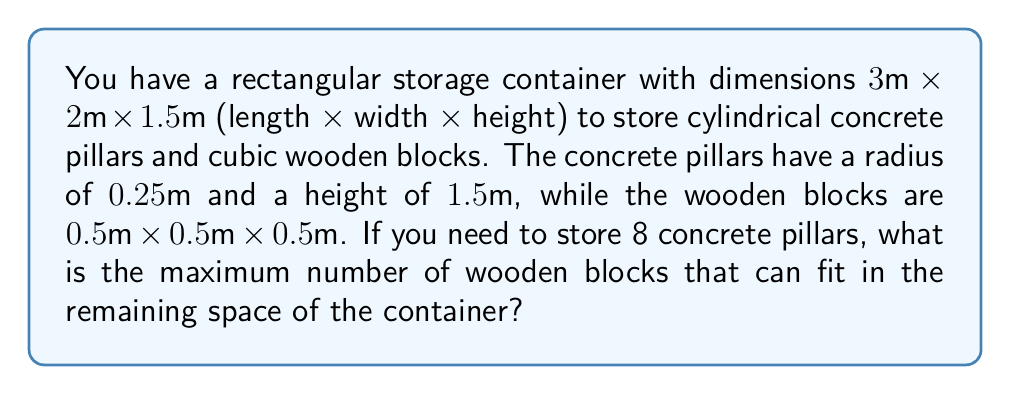Teach me how to tackle this problem. Let's approach this problem step by step:

1. Calculate the volume of the storage container:
   $$V_{container} = 3m \times 2m \times 1.5m = 9m^3$$

2. Calculate the volume of one concrete pillar:
   $$V_{pillar} = \pi r^2 h = \pi \times (0.25m)^2 \times 1.5m \approx 0.2945m^3$$

3. Calculate the total volume occupied by 8 pillars:
   $$V_{8pillars} = 8 \times 0.2945m^3 = 2.356m^3$$

4. Calculate the remaining volume for wooden blocks:
   $$V_{remaining} = V_{container} - V_{8pillars} = 9m^3 - 2.356m^3 = 6.644m^3$$

5. Calculate the volume of one wooden block:
   $$V_{block} = 0.5m \times 0.5m \times 0.5m = 0.125m^3$$

6. Calculate the maximum number of wooden blocks that can fit:
   $$N_{blocks} = \lfloor \frac{V_{remaining}}{V_{block}} \rfloor = \lfloor \frac{6.644m^3}{0.125m^3} \rfloor = \lfloor 53.152 \rfloor = 53$$

   We use the floor function because we can only have whole blocks.

Therefore, a maximum of 53 wooden blocks can fit in the remaining space of the container.
Answer: 53 wooden blocks 